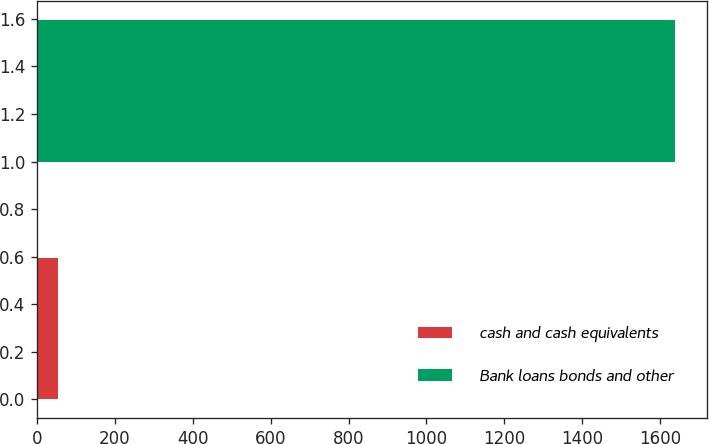Convert chart to OTSL. <chart><loc_0><loc_0><loc_500><loc_500><bar_chart><fcel>cash and cash equivalents<fcel>Bank loans bonds and other<nl><fcel>54<fcel>1639<nl></chart> 